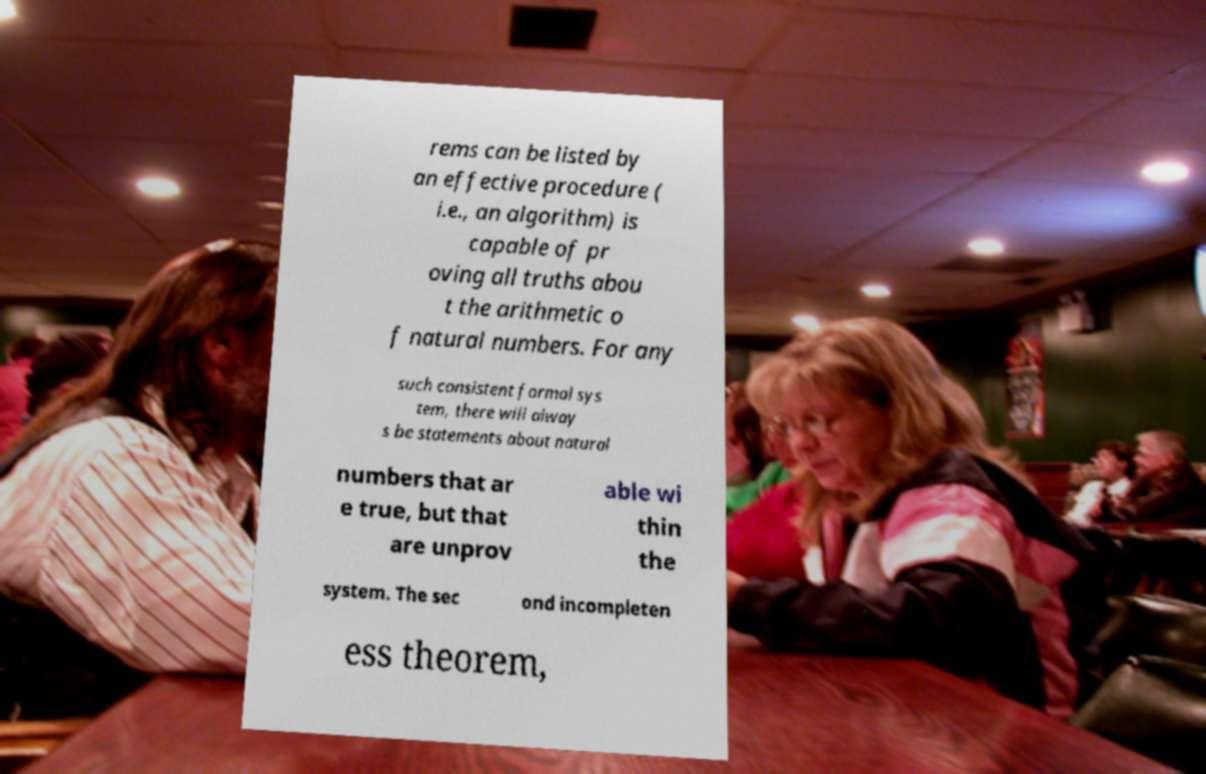Could you extract and type out the text from this image? rems can be listed by an effective procedure ( i.e., an algorithm) is capable of pr oving all truths abou t the arithmetic o f natural numbers. For any such consistent formal sys tem, there will alway s be statements about natural numbers that ar e true, but that are unprov able wi thin the system. The sec ond incompleten ess theorem, 